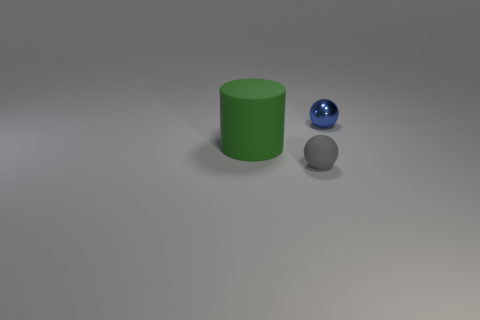Are there any other things that have the same material as the tiny blue ball?
Give a very brief answer. No. There is a small sphere to the left of the tiny shiny ball; is it the same color as the object behind the green object?
Ensure brevity in your answer.  No. What color is the rubber cylinder?
Make the answer very short. Green. Are there any other things of the same color as the tiny metallic sphere?
Offer a terse response. No. What color is the thing that is both in front of the tiny metallic ball and behind the tiny matte ball?
Give a very brief answer. Green. There is a green matte cylinder that is on the left side of the blue shiny sphere; is it the same size as the tiny rubber ball?
Make the answer very short. No. Are there more large green matte cylinders in front of the tiny rubber object than large gray cylinders?
Your answer should be very brief. No. Do the gray matte object and the big matte object have the same shape?
Provide a succinct answer. No. The green cylinder is what size?
Make the answer very short. Large. Is the number of tiny spheres that are in front of the shiny sphere greater than the number of tiny gray things behind the large cylinder?
Make the answer very short. Yes. 